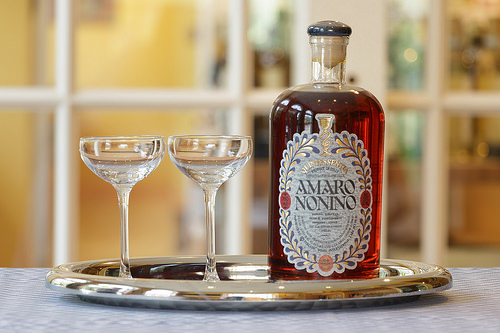<image>
Is there a amaretto next to the plate? No. The amaretto is not positioned next to the plate. They are located in different areas of the scene. 